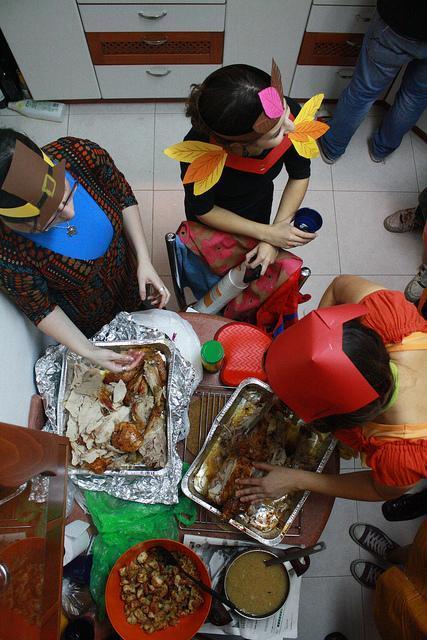How many people can be seen?
Give a very brief answer. 5. How many giraffes are there standing in the sun?
Give a very brief answer. 0. 